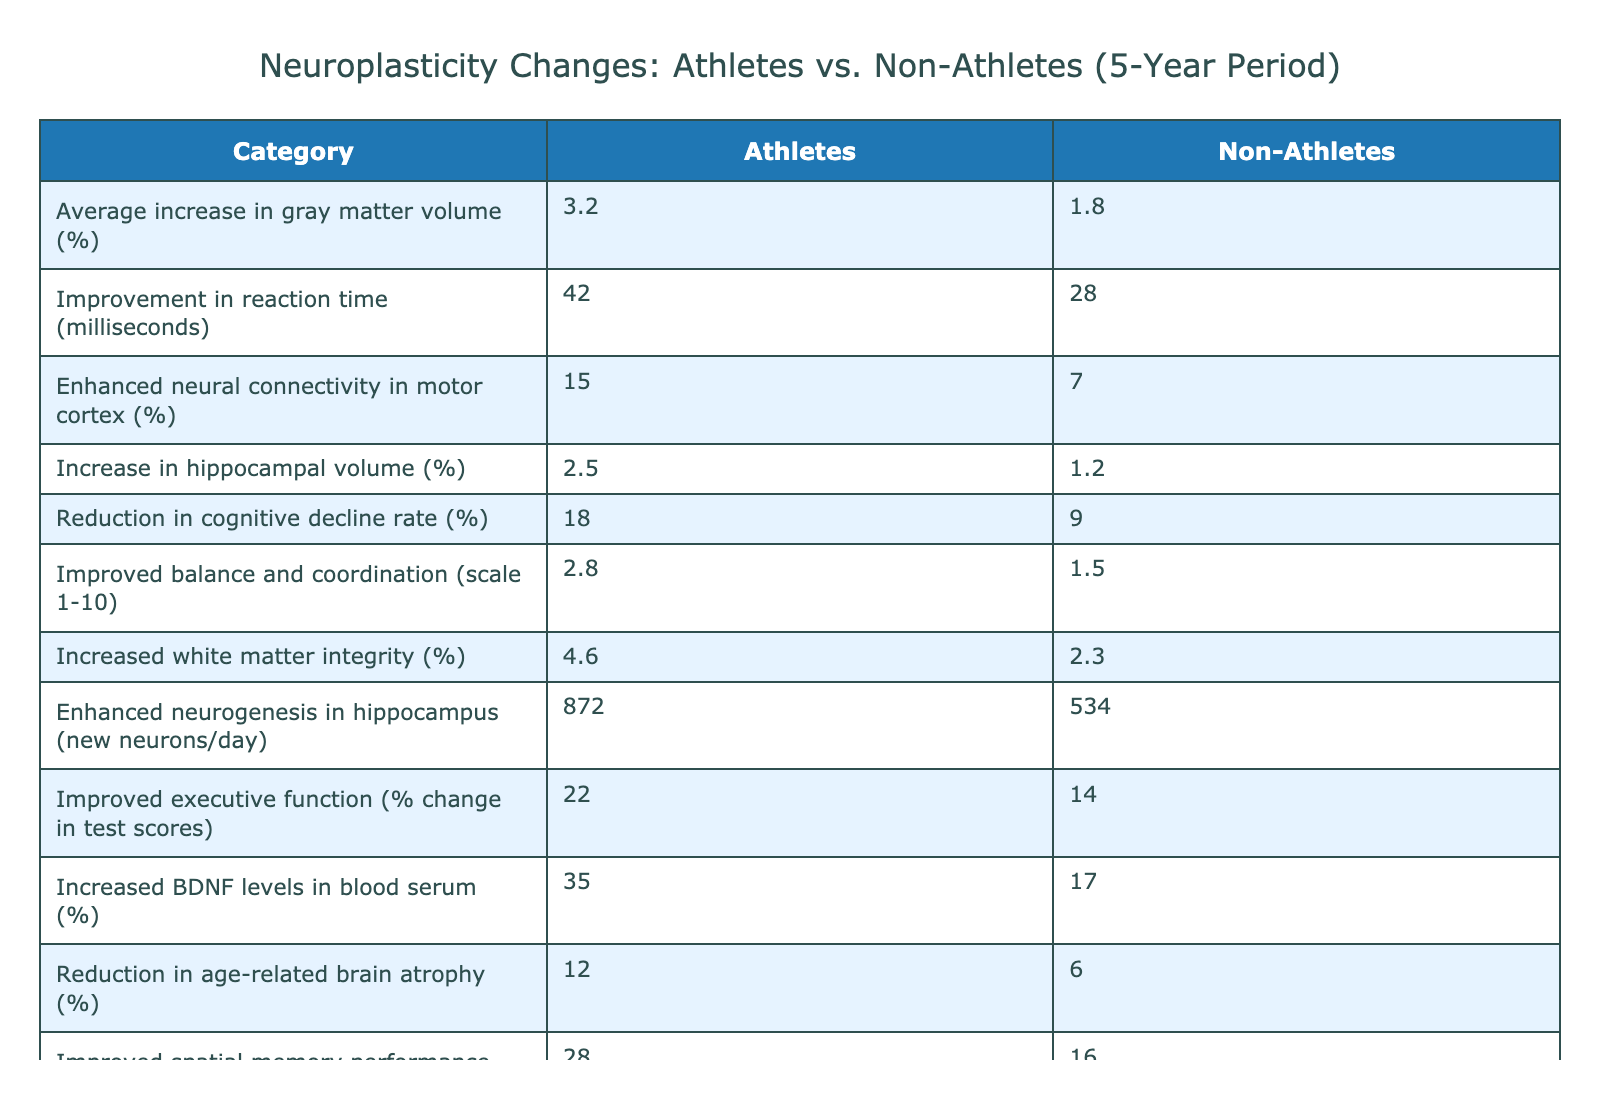What is the average increase in gray matter volume for athletes? From the table, the average increase in gray matter volume for athletes is listed directly as 3.2%.
Answer: 3.2% What percentage increase in hippocampal volume did non-athletes experience? The table states that the increase in hippocampal volume for non-athletes is 1.2%.
Answer: 1.2% What is the difference in reaction time improvement between athletes and non-athletes? Athletes improved their reaction time by 42 milliseconds, while non-athletes improved by 28 milliseconds. Therefore, the difference is 42 - 28 = 14 milliseconds.
Answer: 14 milliseconds Did athletes show a greater reduction in cognitive decline rate compared to non-athletes? The table shows that athletes reduced their cognitive decline rate by 18%, whereas non-athletes reduced theirs by 9%. Since 18% is greater than 9%, the answer is yes.
Answer: Yes What is the average percentage increase in neurogenesis for both groups? For athletes, the neurogenesis increase is 872 new neurons/day, and for non-athletes, it is 534 new neurons/day. The average can be calculated as (872 + 534) / 2 = 703 new neurons/day.
Answer: 703 new neurons/day How much more significant is the enhancement in neural connectivity of athletes compared to non-athletes? The enhancement for athletes is 15%, while non-athletes have 7%. The difference is 15% - 7% = 8%.
Answer: 8% What is the average change in executive function for both athletes and non-athletes? Athletes improved executive function by 22%, and non-athletes by 14%. The average is calculated as (22 + 14) / 2 = 18%.
Answer: 18% Is there any category where the difference in improvement between athletes and non-athletes exceeds 10%? By reviewing the table, we see several categories: the increase in BDNF levels (35% vs 17% gives a difference of 18%), spatial memory performance (28% vs 16% gives a difference of 12%), and others also exceed 10%. Thus, the answer is yes.
Answer: Yes How much greater is the reduction in stress-related cortisol levels in athletes compared to non-athletes? Athletes had a reduction of 30% in cortisol levels while non-athletes had a reduction of 18%. Subtracting these gives us 30% - 18% = 12%.
Answer: 12% 